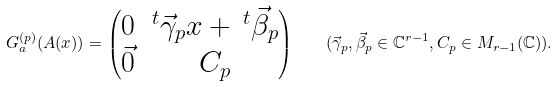<formula> <loc_0><loc_0><loc_500><loc_500>G _ { a } ^ { ( p ) } ( A ( x ) ) = \begin{pmatrix} 0 & ^ { t } \vec { \gamma } _ { p } x + \, ^ { t } \vec { \beta } _ { p } \\ \vec { 0 } & C _ { p } \end{pmatrix} \quad ( \vec { \gamma } _ { p } , \vec { \beta } _ { p } \in \mathbb { C } ^ { r - 1 } , C _ { p } \in M _ { r - 1 } ( \mathbb { C } ) ) .</formula> 